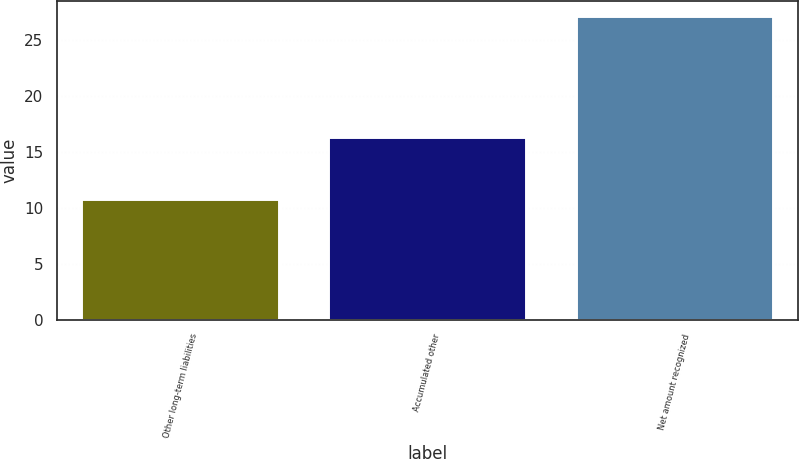Convert chart. <chart><loc_0><loc_0><loc_500><loc_500><bar_chart><fcel>Other long-term liabilities<fcel>Accumulated other<fcel>Net amount recognized<nl><fcel>10.8<fcel>16.3<fcel>27.1<nl></chart> 